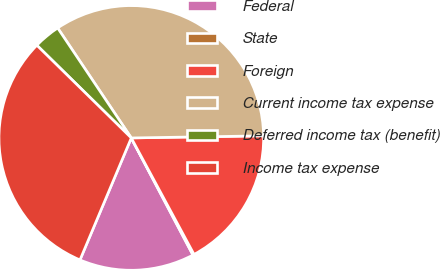<chart> <loc_0><loc_0><loc_500><loc_500><pie_chart><fcel>Federal<fcel>State<fcel>Foreign<fcel>Current income tax expense<fcel>Deferred income tax (benefit)<fcel>Income tax expense<nl><fcel>14.05%<fcel>0.15%<fcel>17.39%<fcel>34.13%<fcel>3.26%<fcel>31.01%<nl></chart> 